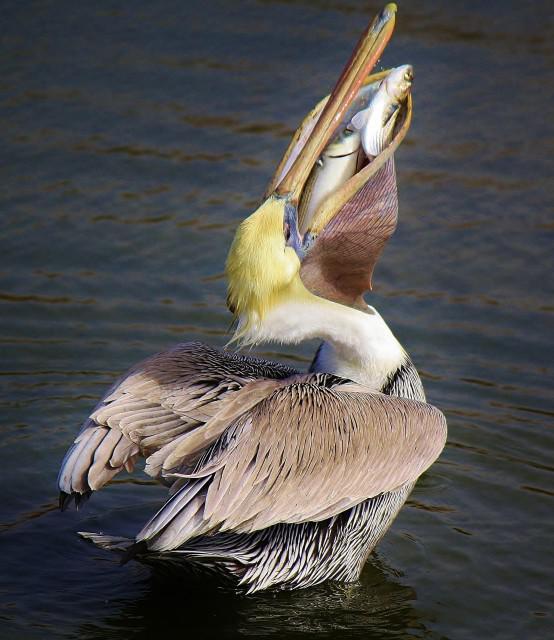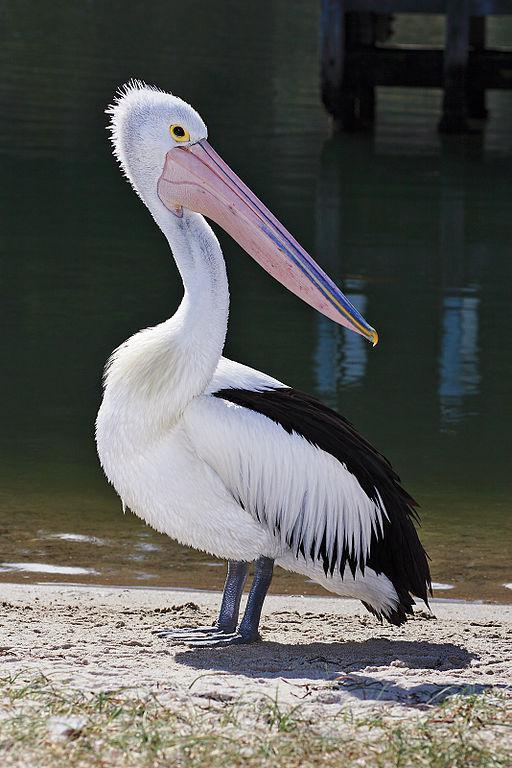The first image is the image on the left, the second image is the image on the right. For the images displayed, is the sentence "The bird on the left has a fish, but there are no fish in the right image." factually correct? Answer yes or no. Yes. 